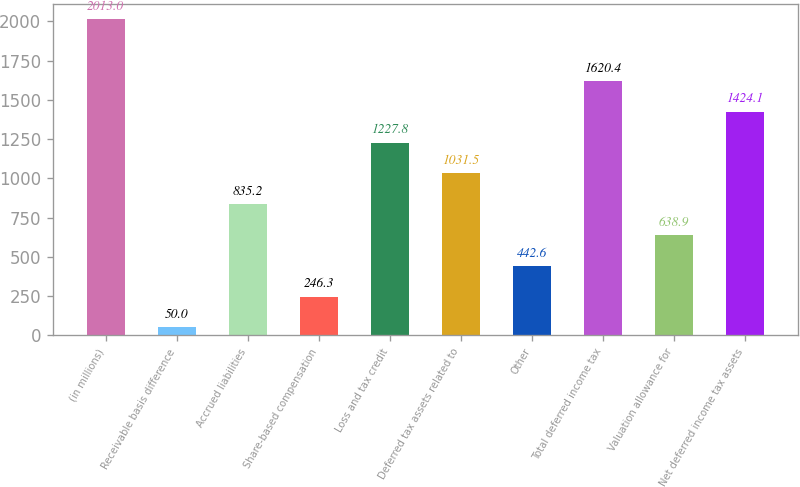Convert chart to OTSL. <chart><loc_0><loc_0><loc_500><loc_500><bar_chart><fcel>(in millions)<fcel>Receivable basis difference<fcel>Accrued liabilities<fcel>Share-based compensation<fcel>Loss and tax credit<fcel>Deferred tax assets related to<fcel>Other<fcel>Total deferred income tax<fcel>Valuation allowance for<fcel>Net deferred income tax assets<nl><fcel>2013<fcel>50<fcel>835.2<fcel>246.3<fcel>1227.8<fcel>1031.5<fcel>442.6<fcel>1620.4<fcel>638.9<fcel>1424.1<nl></chart> 